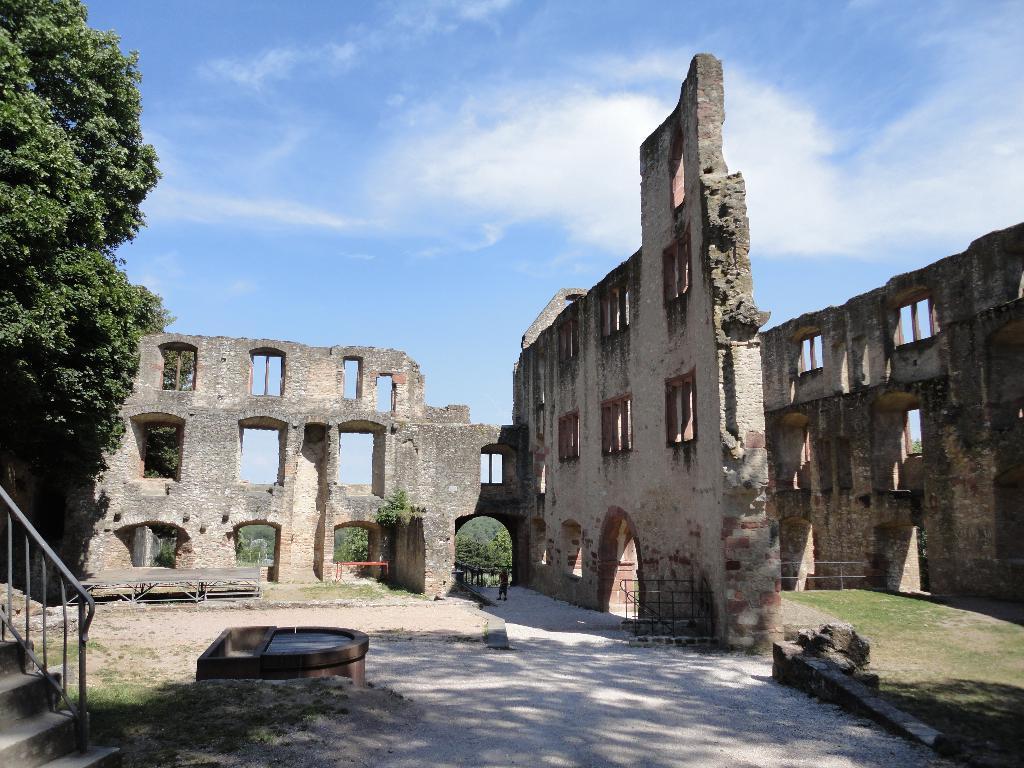In one or two sentences, can you explain what this image depicts? In the foreground of this image, there is path. On the left, there are steps, railing and trees. In the background, there are arches and windows to the walls. On the top, there is the sky and the cloud. 